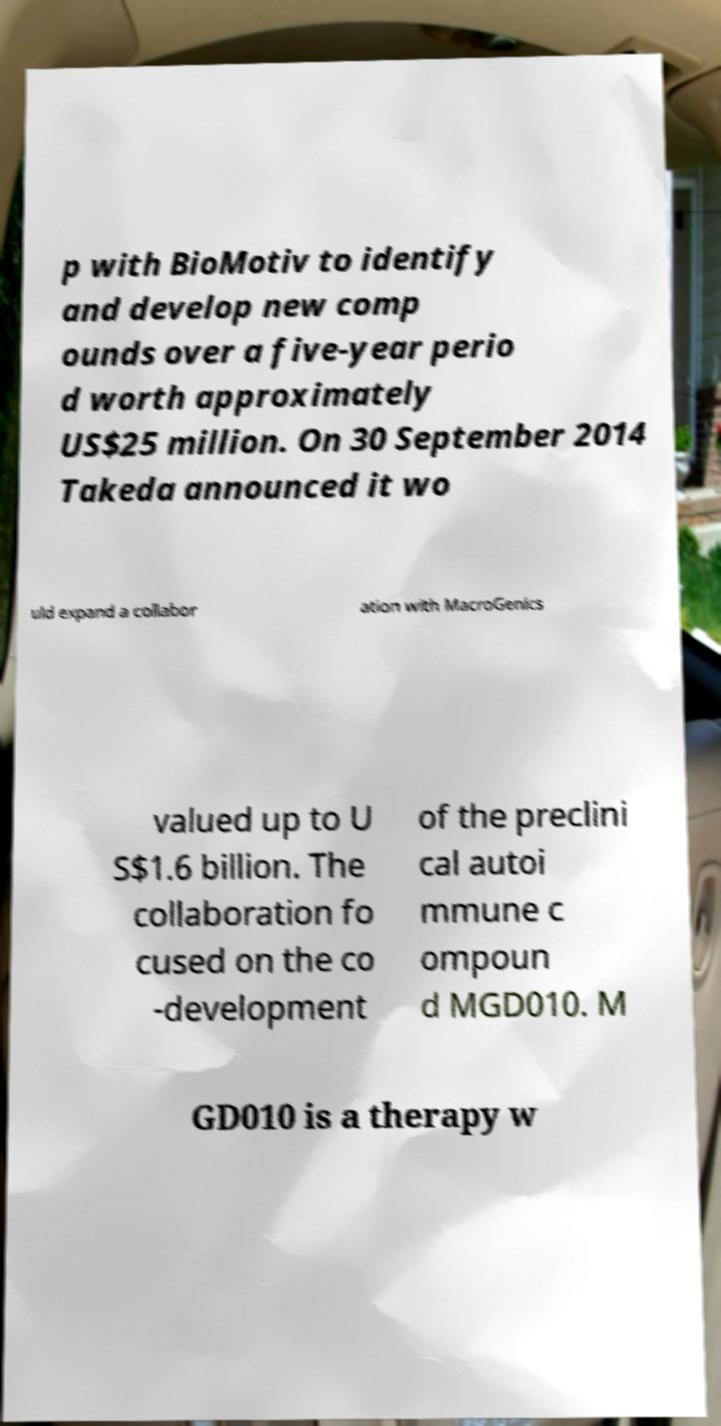Could you assist in decoding the text presented in this image and type it out clearly? p with BioMotiv to identify and develop new comp ounds over a five-year perio d worth approximately US$25 million. On 30 September 2014 Takeda announced it wo uld expand a collabor ation with MacroGenics valued up to U S$1.6 billion. The collaboration fo cused on the co -development of the preclini cal autoi mmune c ompoun d MGD010. M GD010 is a therapy w 